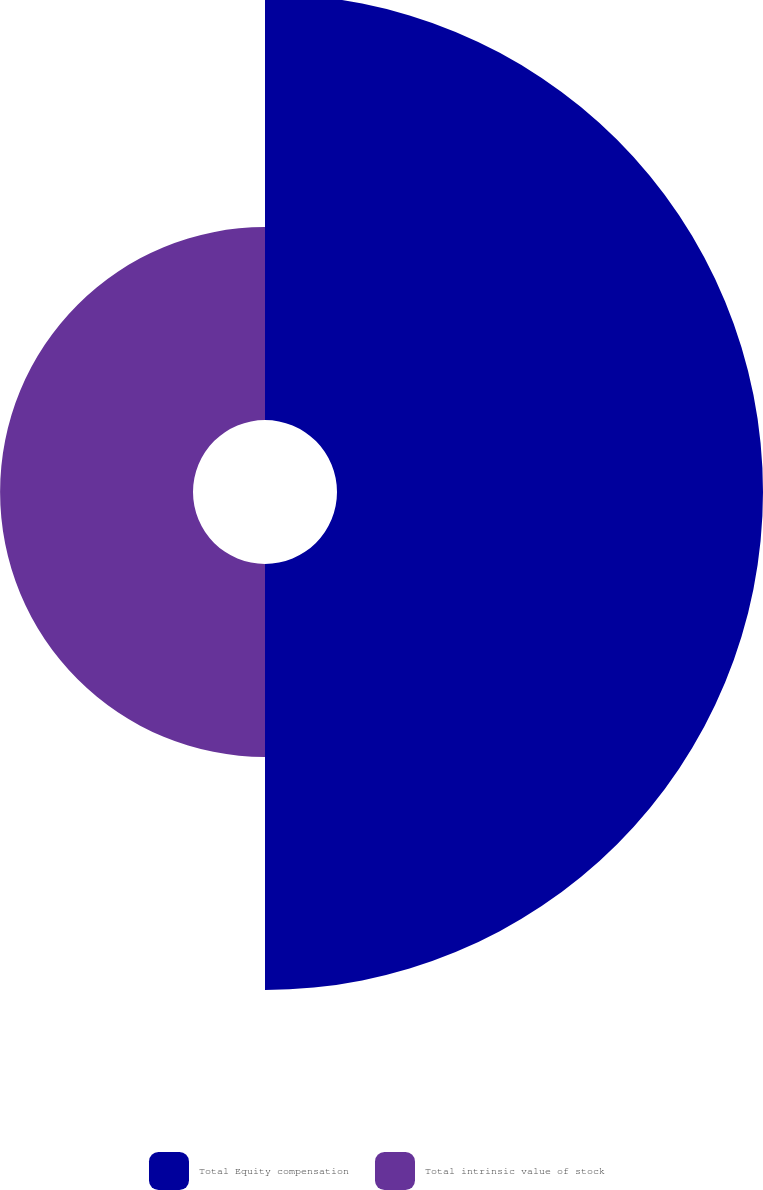Convert chart to OTSL. <chart><loc_0><loc_0><loc_500><loc_500><pie_chart><fcel>Total Equity compensation<fcel>Total intrinsic value of stock<nl><fcel>68.83%<fcel>31.17%<nl></chart> 